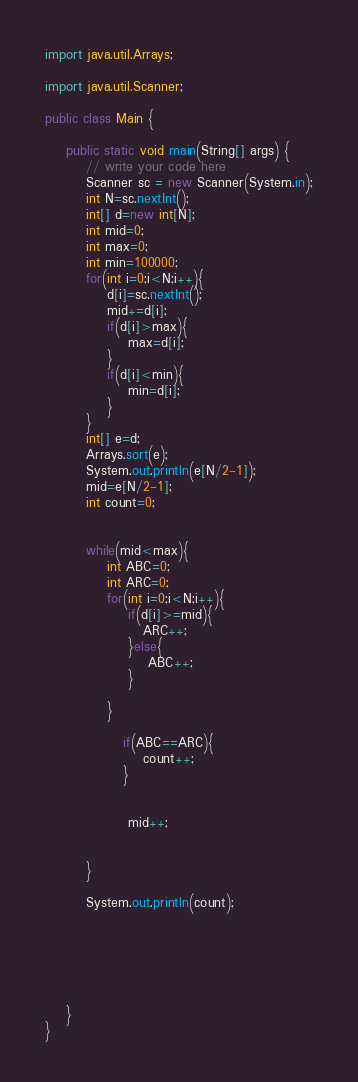Convert code to text. <code><loc_0><loc_0><loc_500><loc_500><_Java_>import java.util.Arrays;

import java.util.Scanner;

public class Main {

    public static void main(String[] args) {
        // write your code here
        Scanner sc = new Scanner(System.in);
        int N=sc.nextInt();
        int[] d=new int[N];
        int mid=0;
        int max=0;
        int min=100000;
        for(int i=0;i<N;i++){
            d[i]=sc.nextInt();
            mid+=d[i];
            if(d[i]>max){
                max=d[i];
            }
            if(d[i]<min){
                min=d[i];
            }
        }
        int[] e=d;
        Arrays.sort(e);
        System.out.println(e[N/2-1]);
        mid=e[N/2-1];
        int count=0;


        while(mid<max){
            int ABC=0;
            int ARC=0;
            for(int i=0;i<N;i++){
                if(d[i]>=mid){
                   ARC++;
                }else{
                    ABC++;
                }

            }

               if(ABC==ARC){
                   count++;
               }


                mid++;


        }

        System.out.println(count);






    }
}
</code> 